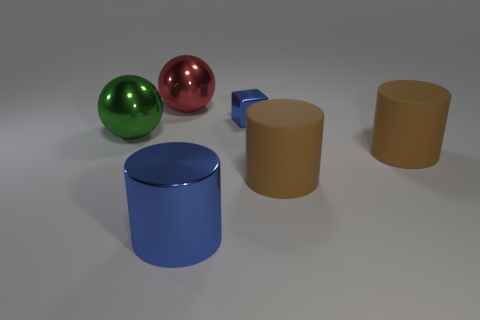What material is the cylinder that is the same color as the tiny object?
Your answer should be compact. Metal. Is the tiny shiny thing the same color as the big shiny cylinder?
Ensure brevity in your answer.  Yes. The thing that is behind the big green metallic object and in front of the big red shiny object is what color?
Give a very brief answer. Blue. Are there more big red objects than big shiny spheres?
Provide a short and direct response. No. There is a big object behind the small blue metallic block; is its shape the same as the green object?
Make the answer very short. Yes. How many shiny things are cylinders or big brown things?
Ensure brevity in your answer.  1. Are there any large things made of the same material as the big blue cylinder?
Your response must be concise. Yes. What is the big red ball made of?
Offer a very short reply. Metal. What is the shape of the big object behind the large shiny ball left of the large sphere that is on the right side of the big green shiny object?
Ensure brevity in your answer.  Sphere. Is the number of large spheres that are in front of the red shiny object greater than the number of tiny gray balls?
Your answer should be compact. Yes. 